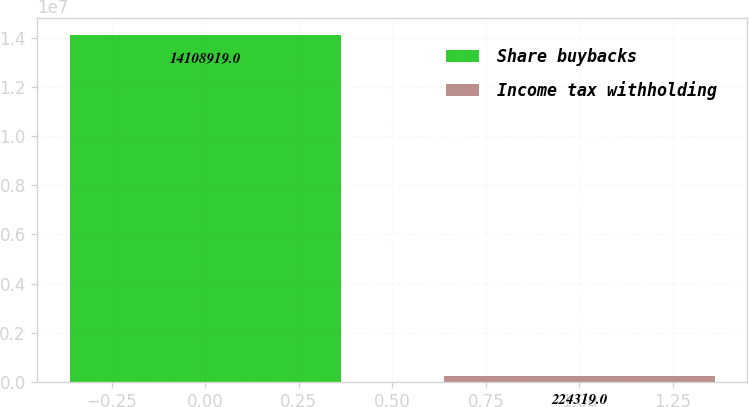Convert chart to OTSL. <chart><loc_0><loc_0><loc_500><loc_500><bar_chart><fcel>Share buybacks<fcel>Income tax withholding<nl><fcel>1.41089e+07<fcel>224319<nl></chart> 